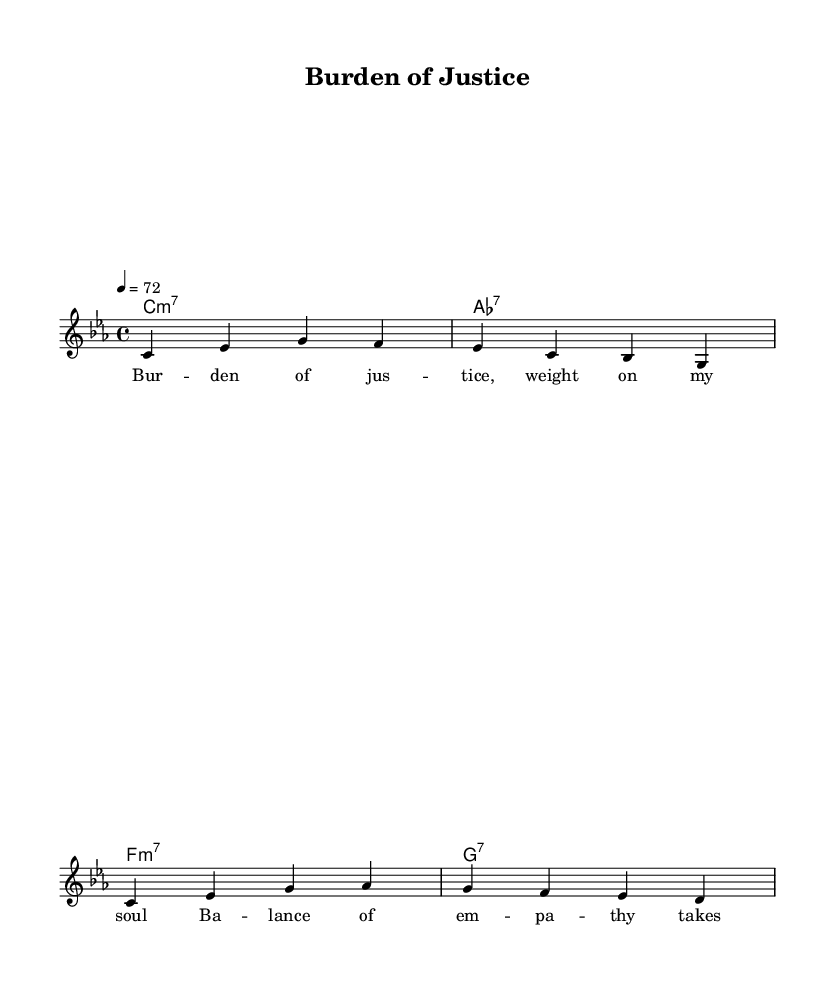What is the key signature of this music? The key signature displayed in the sheet music indicates that the key is C minor, which typically includes three flats. This can be deduced from the initial part of the global settings, where it specifies "\key c \minor".
Answer: C minor What is the time signature of this music? The time signature is shown in the global settings and is 4/4, which means there are four beats per measure. This is indicated by "\time 4/4" in the code.
Answer: 4/4 What is the tempo of this piece? The tempo marking states "4 = 72", meaning there are 72 beats per minute. The tempo is set in the global settings and dictates the speed of the piece.
Answer: 72 What type of chord follows the melody in the first measure? In the chord mode section, the first chord listed is a C minor seventh chord (C:m7), which aligns with the melody played over that measure. This is determined by viewing the chords in relation to the melody.
Answer: C:m7 What is the emotional theme reflected in the lyrics? The lyrics outline themes of justice and empathy, as indicated by the phrases "Burden of justice, weight on my soul" and "Balance of empathy takes its toll", showing a deep emotional connection to the consequences of sentencing. This theme is typical in R&B music that reflects personal struggles.
Answer: Burden of justice What style of music is this piece classified under? The piece is classified under Rhythm and Blues (R&B), which is noted for its emotional expression and connection to personal storytelling, such as the emotional toll of sentencing criminals depicted in the lyrics and melodic structure.
Answer: Rhythm and Blues 